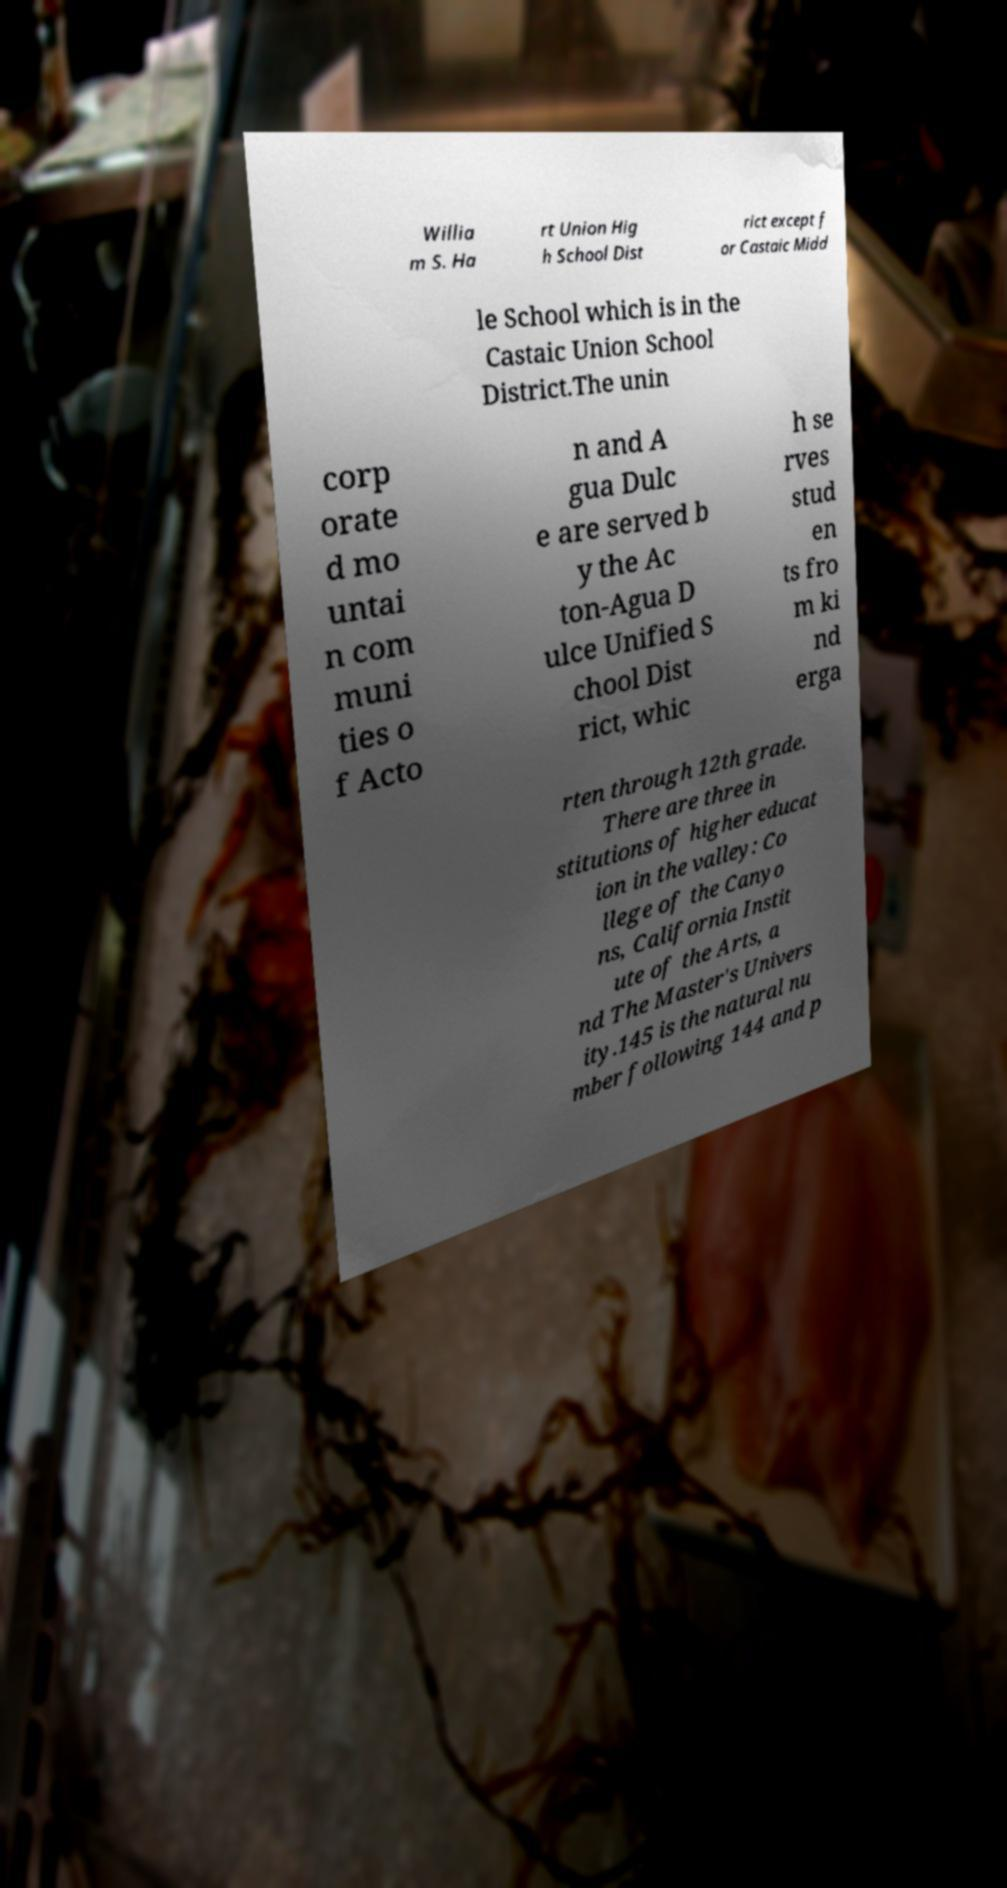Could you assist in decoding the text presented in this image and type it out clearly? Willia m S. Ha rt Union Hig h School Dist rict except f or Castaic Midd le School which is in the Castaic Union School District.The unin corp orate d mo untai n com muni ties o f Acto n and A gua Dulc e are served b y the Ac ton-Agua D ulce Unified S chool Dist rict, whic h se rves stud en ts fro m ki nd erga rten through 12th grade. There are three in stitutions of higher educat ion in the valley: Co llege of the Canyo ns, California Instit ute of the Arts, a nd The Master's Univers ity.145 is the natural nu mber following 144 and p 